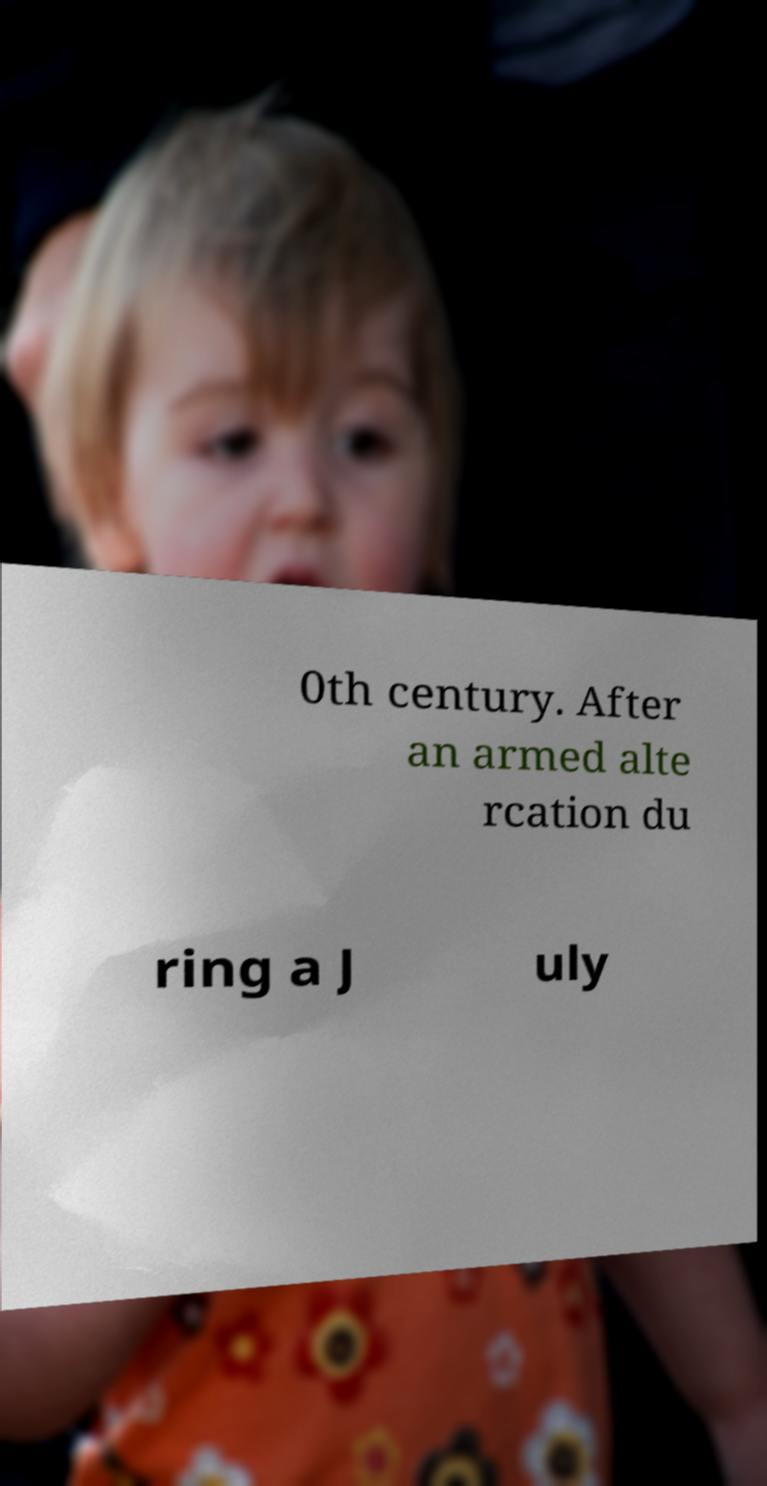What messages or text are displayed in this image? I need them in a readable, typed format. 0th century. After an armed alte rcation du ring a J uly 